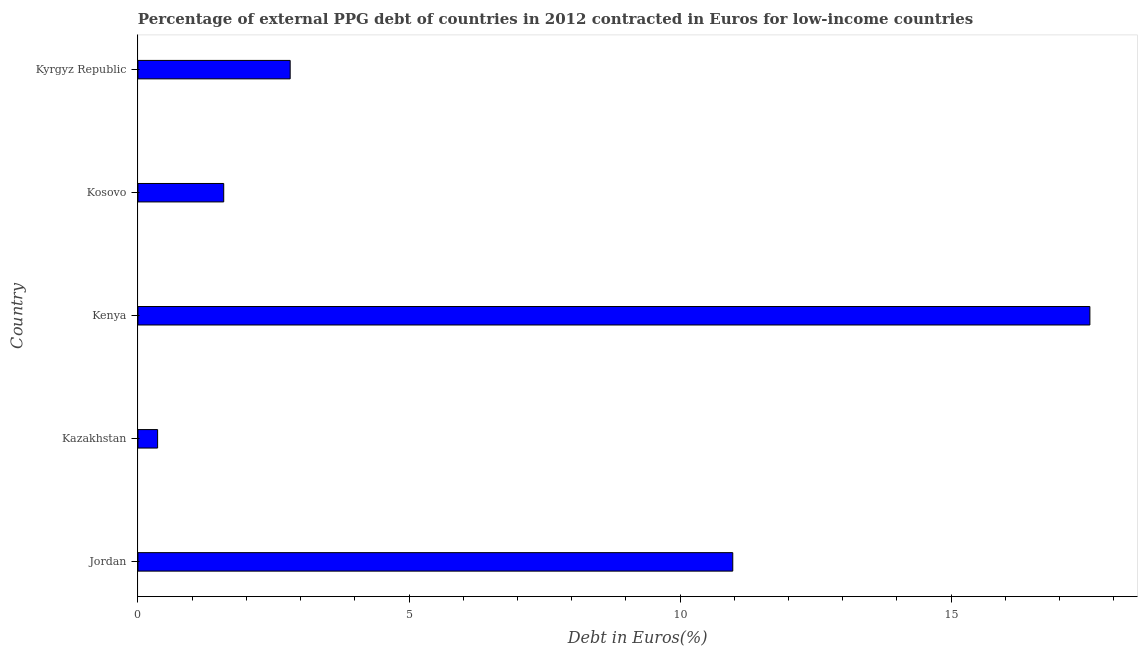Does the graph contain any zero values?
Provide a short and direct response. No. Does the graph contain grids?
Keep it short and to the point. No. What is the title of the graph?
Your answer should be very brief. Percentage of external PPG debt of countries in 2012 contracted in Euros for low-income countries. What is the label or title of the X-axis?
Offer a terse response. Debt in Euros(%). What is the label or title of the Y-axis?
Your answer should be very brief. Country. What is the currency composition of ppg debt in Kyrgyz Republic?
Offer a very short reply. 2.81. Across all countries, what is the maximum currency composition of ppg debt?
Offer a terse response. 17.56. Across all countries, what is the minimum currency composition of ppg debt?
Offer a terse response. 0.36. In which country was the currency composition of ppg debt maximum?
Make the answer very short. Kenya. In which country was the currency composition of ppg debt minimum?
Your answer should be compact. Kazakhstan. What is the sum of the currency composition of ppg debt?
Provide a short and direct response. 33.29. What is the difference between the currency composition of ppg debt in Kazakhstan and Kenya?
Give a very brief answer. -17.2. What is the average currency composition of ppg debt per country?
Your answer should be very brief. 6.66. What is the median currency composition of ppg debt?
Ensure brevity in your answer.  2.81. What is the ratio of the currency composition of ppg debt in Kenya to that in Kyrgyz Republic?
Your answer should be compact. 6.25. Is the currency composition of ppg debt in Kazakhstan less than that in Kenya?
Provide a short and direct response. Yes. What is the difference between the highest and the second highest currency composition of ppg debt?
Keep it short and to the point. 6.59. What is the difference between the highest and the lowest currency composition of ppg debt?
Keep it short and to the point. 17.2. In how many countries, is the currency composition of ppg debt greater than the average currency composition of ppg debt taken over all countries?
Your answer should be very brief. 2. How many bars are there?
Offer a terse response. 5. How many countries are there in the graph?
Offer a terse response. 5. Are the values on the major ticks of X-axis written in scientific E-notation?
Offer a terse response. No. What is the Debt in Euros(%) in Jordan?
Your answer should be very brief. 10.97. What is the Debt in Euros(%) of Kazakhstan?
Your answer should be compact. 0.36. What is the Debt in Euros(%) of Kenya?
Offer a terse response. 17.56. What is the Debt in Euros(%) of Kosovo?
Your response must be concise. 1.58. What is the Debt in Euros(%) in Kyrgyz Republic?
Ensure brevity in your answer.  2.81. What is the difference between the Debt in Euros(%) in Jordan and Kazakhstan?
Offer a very short reply. 10.61. What is the difference between the Debt in Euros(%) in Jordan and Kenya?
Your response must be concise. -6.59. What is the difference between the Debt in Euros(%) in Jordan and Kosovo?
Keep it short and to the point. 9.39. What is the difference between the Debt in Euros(%) in Jordan and Kyrgyz Republic?
Keep it short and to the point. 8.16. What is the difference between the Debt in Euros(%) in Kazakhstan and Kenya?
Make the answer very short. -17.2. What is the difference between the Debt in Euros(%) in Kazakhstan and Kosovo?
Ensure brevity in your answer.  -1.22. What is the difference between the Debt in Euros(%) in Kazakhstan and Kyrgyz Republic?
Keep it short and to the point. -2.45. What is the difference between the Debt in Euros(%) in Kenya and Kosovo?
Ensure brevity in your answer.  15.98. What is the difference between the Debt in Euros(%) in Kenya and Kyrgyz Republic?
Your answer should be very brief. 14.75. What is the difference between the Debt in Euros(%) in Kosovo and Kyrgyz Republic?
Keep it short and to the point. -1.23. What is the ratio of the Debt in Euros(%) in Jordan to that in Kazakhstan?
Give a very brief answer. 30.26. What is the ratio of the Debt in Euros(%) in Jordan to that in Kosovo?
Provide a succinct answer. 6.94. What is the ratio of the Debt in Euros(%) in Jordan to that in Kyrgyz Republic?
Offer a very short reply. 3.91. What is the ratio of the Debt in Euros(%) in Kazakhstan to that in Kenya?
Your answer should be compact. 0.02. What is the ratio of the Debt in Euros(%) in Kazakhstan to that in Kosovo?
Your answer should be compact. 0.23. What is the ratio of the Debt in Euros(%) in Kazakhstan to that in Kyrgyz Republic?
Give a very brief answer. 0.13. What is the ratio of the Debt in Euros(%) in Kenya to that in Kosovo?
Keep it short and to the point. 11.1. What is the ratio of the Debt in Euros(%) in Kenya to that in Kyrgyz Republic?
Offer a terse response. 6.25. What is the ratio of the Debt in Euros(%) in Kosovo to that in Kyrgyz Republic?
Make the answer very short. 0.56. 